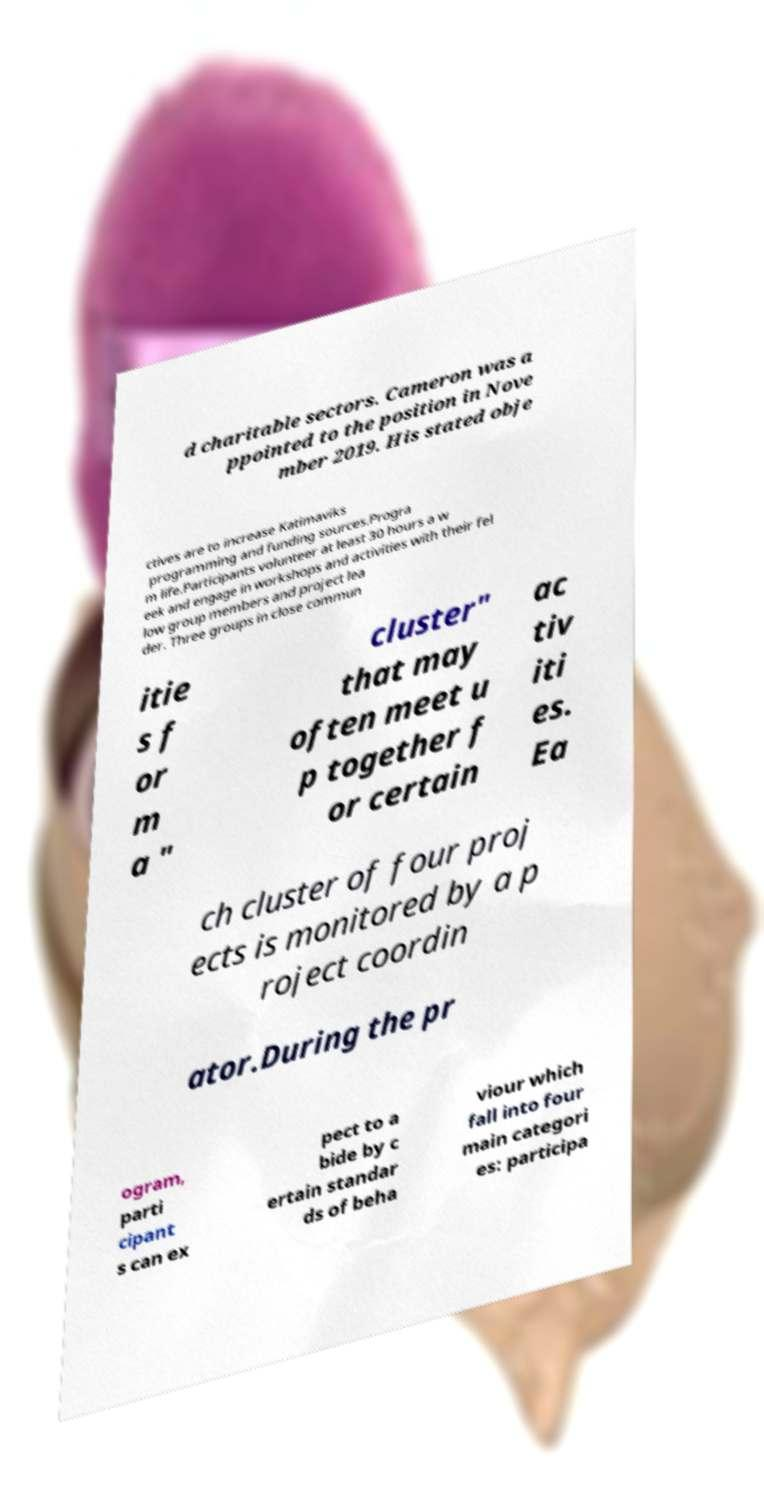Please read and relay the text visible in this image. What does it say? d charitable sectors. Cameron was a ppointed to the position in Nove mber 2019. His stated obje ctives are to increase Katimaviks programming and funding sources.Progra m life.Participants volunteer at least 30 hours a w eek and engage in workshops and activities with their fel low group members and project lea der. Three groups in close commun itie s f or m a " cluster" that may often meet u p together f or certain ac tiv iti es. Ea ch cluster of four proj ects is monitored by a p roject coordin ator.During the pr ogram, parti cipant s can ex pect to a bide by c ertain standar ds of beha viour which fall into four main categori es: participa 